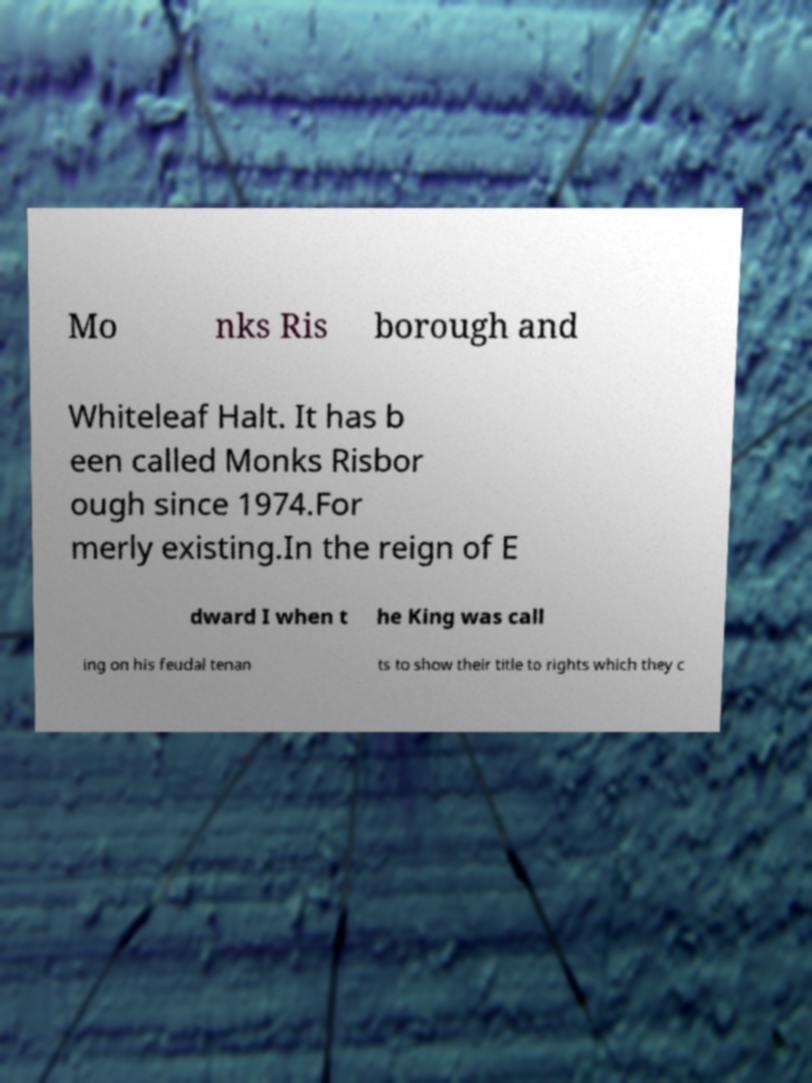Can you read and provide the text displayed in the image?This photo seems to have some interesting text. Can you extract and type it out for me? Mo nks Ris borough and Whiteleaf Halt. It has b een called Monks Risbor ough since 1974.For merly existing.In the reign of E dward I when t he King was call ing on his feudal tenan ts to show their title to rights which they c 